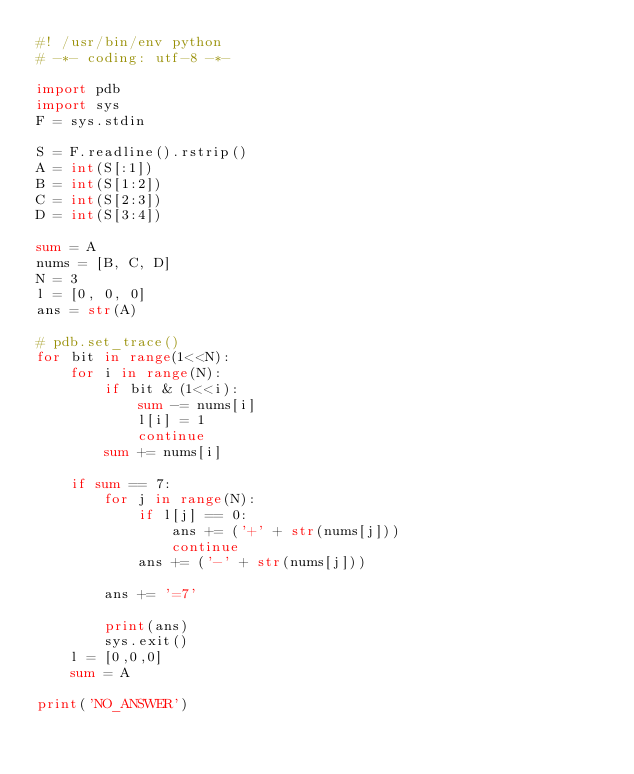<code> <loc_0><loc_0><loc_500><loc_500><_Python_>#! /usr/bin/env python
# -*- coding: utf-8 -*-

import pdb
import sys
F = sys.stdin

S = F.readline().rstrip()
A = int(S[:1])
B = int(S[1:2])
C = int(S[2:3])
D = int(S[3:4])

sum = A
nums = [B, C, D]
N = 3
l = [0, 0, 0]
ans = str(A)

# pdb.set_trace()
for bit in range(1<<N):
    for i in range(N):
        if bit & (1<<i):
            sum -= nums[i]
            l[i] = 1
            continue
        sum += nums[i]

    if sum == 7:
        for j in range(N):
            if l[j] == 0:
                ans += ('+' + str(nums[j]))
                continue
            ans += ('-' + str(nums[j]))

        ans += '=7'

        print(ans)
        sys.exit()
    l = [0,0,0]
    sum = A

print('NO_ANSWER')
</code> 